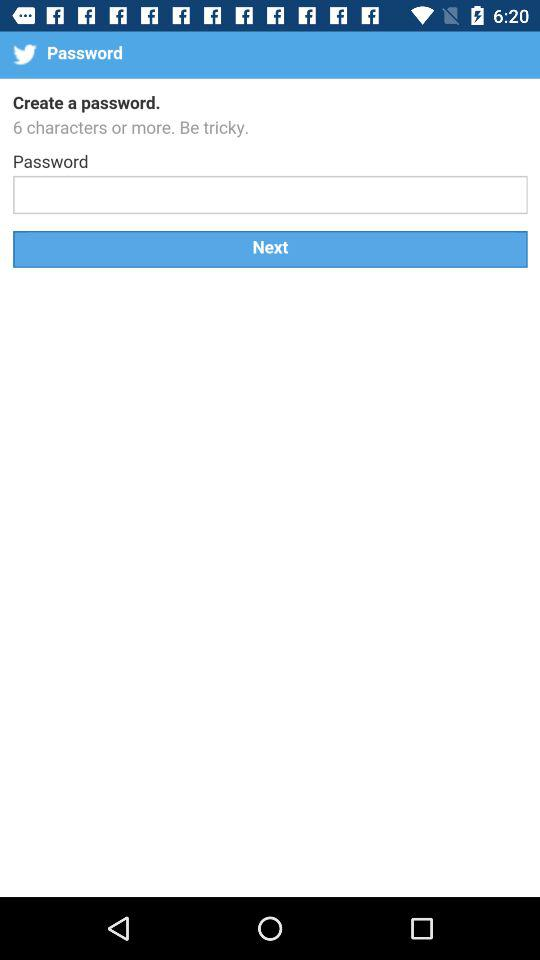How many characters should a password have? A password should have 6 characters or more. 